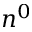<formula> <loc_0><loc_0><loc_500><loc_500>n ^ { 0 }</formula> 